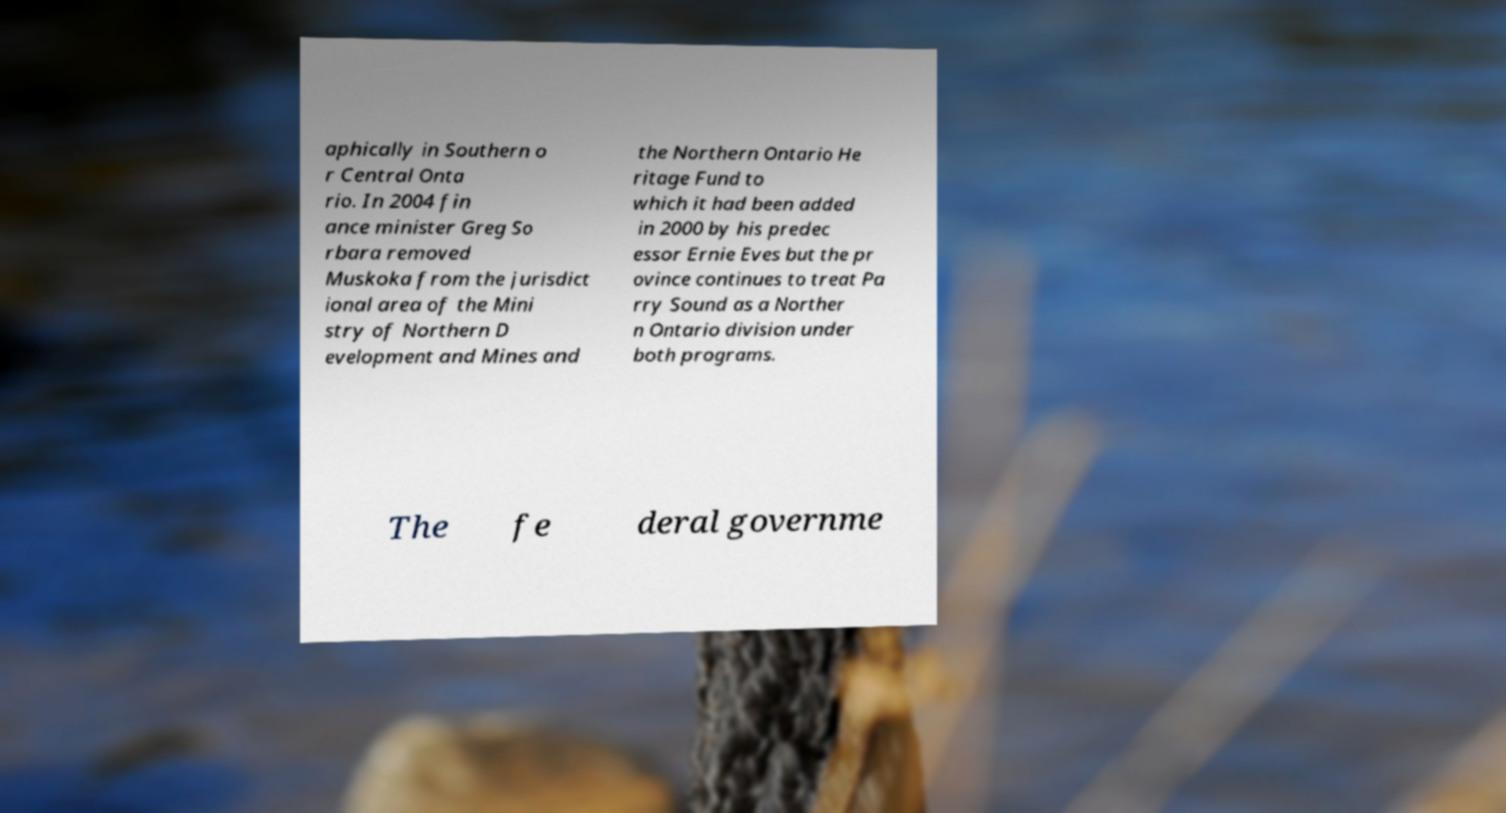Please read and relay the text visible in this image. What does it say? aphically in Southern o r Central Onta rio. In 2004 fin ance minister Greg So rbara removed Muskoka from the jurisdict ional area of the Mini stry of Northern D evelopment and Mines and the Northern Ontario He ritage Fund to which it had been added in 2000 by his predec essor Ernie Eves but the pr ovince continues to treat Pa rry Sound as a Norther n Ontario division under both programs. The fe deral governme 